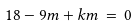<formula> <loc_0><loc_0><loc_500><loc_500>1 8 - 9 m + k m \, = \, 0</formula> 